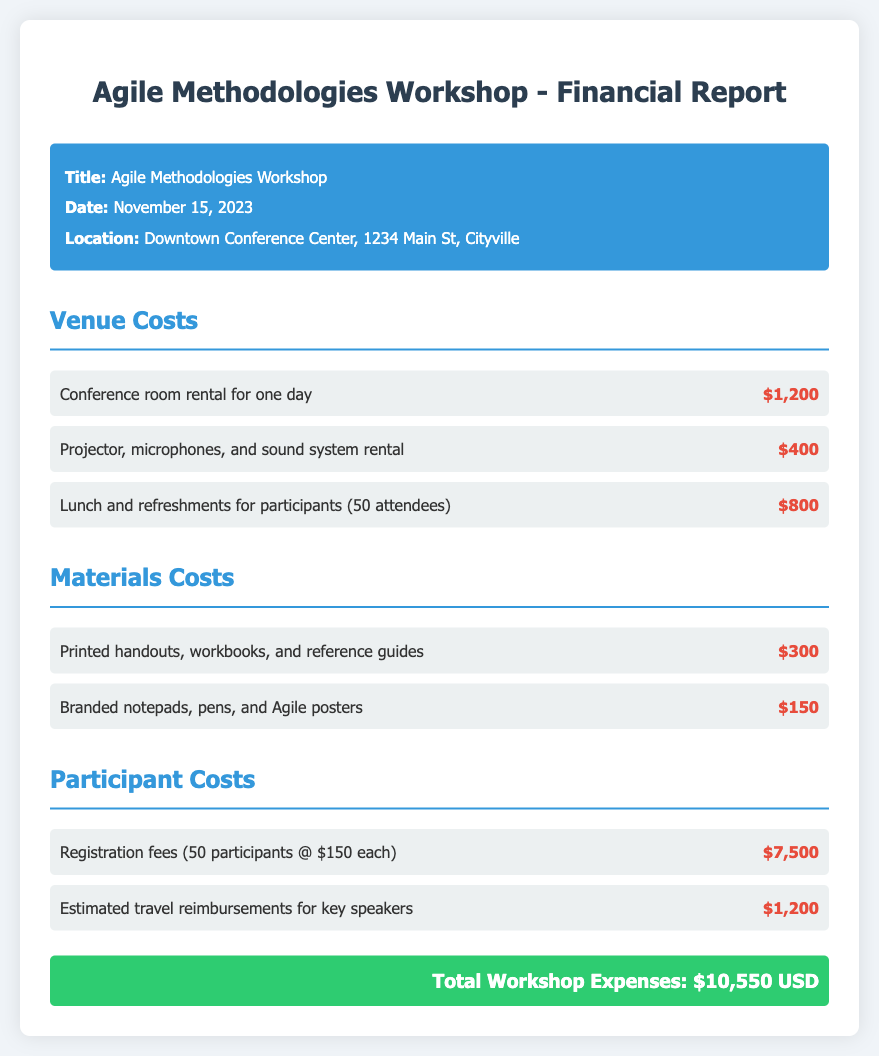What is the title of the workshop? The title is stated in the "workshop-details" section of the document.
Answer: Agile Methodologies Workshop What is the date of the workshop? The date is provided in the "workshop-details" section.
Answer: November 15, 2023 How much did the conference room rental cost? The cost is listed under the "Venue Costs" section of the document.
Answer: $1,200 What is the total workshop expense? The total expense is summarized at the end of the document.
Answer: $10,550 USD How many participants were estimated for the registration fees? This number is indicated in the "Participant Costs" section related to registration.
Answer: 50 participants What was the cost of printed materials? The cost can be found in the "Materials Costs" section of the document.
Answer: $300 What items were included in the lunch and refreshments expense? This information is stated in the "Venue Costs" section regarding food for participants.
Answer: Lunch and refreshments for participants (50 attendees) What is the cost of branded notepads, pens, and posters? This expense is listed under the "Materials Costs" section of the report.
Answer: $150 What type of venue was used for the workshop? The type of venue is indicated in the "workshop-details" section of the document.
Answer: Downtown Conference Center 